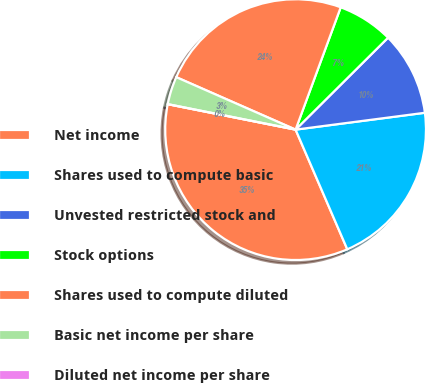<chart> <loc_0><loc_0><loc_500><loc_500><pie_chart><fcel>Net income<fcel>Shares used to compute basic<fcel>Unvested restricted stock and<fcel>Stock options<fcel>Shares used to compute diluted<fcel>Basic net income per share<fcel>Diluted net income per share<nl><fcel>34.62%<fcel>20.57%<fcel>10.39%<fcel>6.92%<fcel>24.03%<fcel>3.46%<fcel>0.0%<nl></chart> 